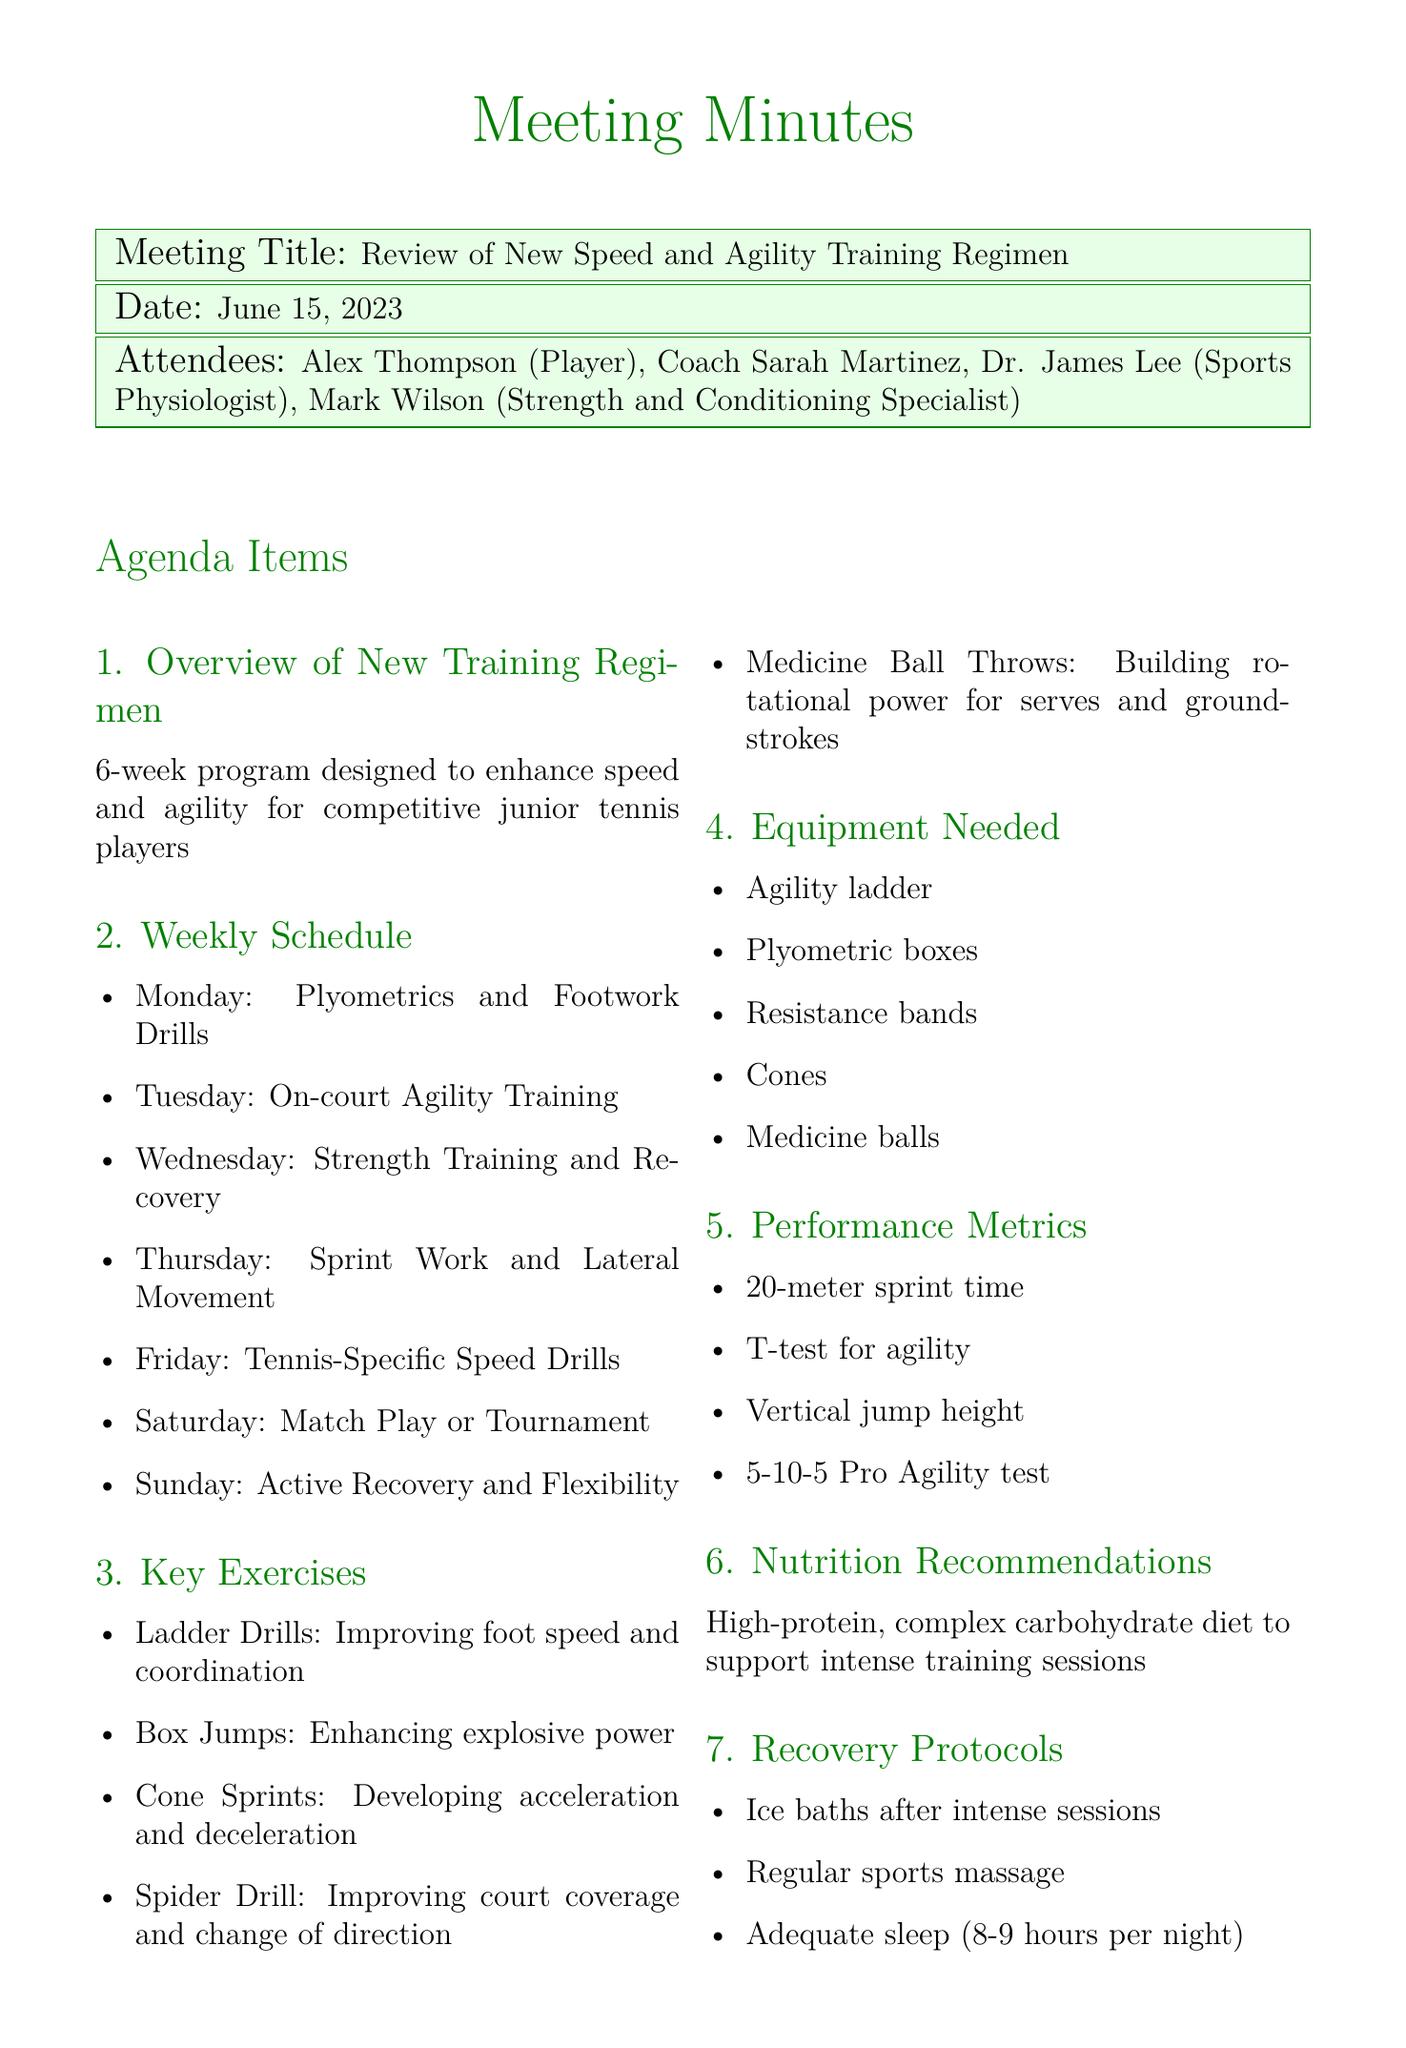What is the title of the meeting? The title of the meeting is clearly stated at the beginning of the document.
Answer: Review of New Speed and Agility Training Regimen When did the meeting take place? The date of the meeting is mentioned in the document.
Answer: June 15, 2023 Who is responsible for monitoring Alex's progress? The action items specify who will be monitoring Alex's progress during the training regimen.
Answer: Coach Sarah What exercise is used to improve foot speed and coordination? The document lists specific exercises and their purposes, including the one for foot speed.
Answer: Ladder Drills What day is designated for active recovery and flexibility? The weekly schedule outlines specific activities assigned to each day of the week.
Answer: Sunday What type of diet is recommended for training? The nutrition recommendations section describes the type of diet that should be followed.
Answer: High-protein, complex carbohydrate diet What is one performance metric mentioned in the meeting? The performance metrics section lists specific metrics that will be used to assess progress.
Answer: 20-meter sprint time How many weeks does the training regimen last? The duration of the training program is mentioned in the overview section.
Answer: 6 weeks 